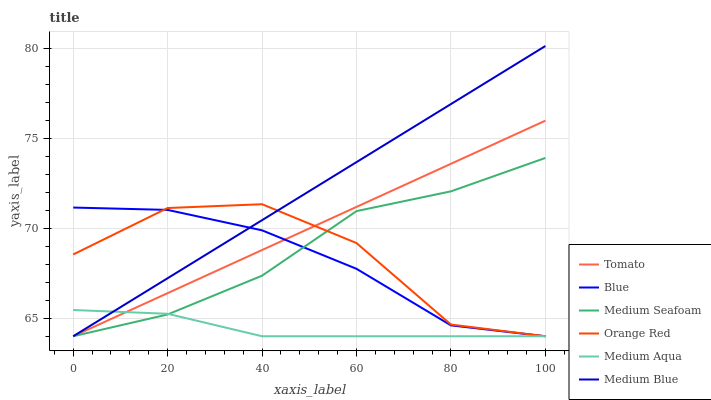Does Medium Aqua have the minimum area under the curve?
Answer yes or no. Yes. Does Medium Blue have the maximum area under the curve?
Answer yes or no. Yes. Does Blue have the minimum area under the curve?
Answer yes or no. No. Does Blue have the maximum area under the curve?
Answer yes or no. No. Is Tomato the smoothest?
Answer yes or no. Yes. Is Orange Red the roughest?
Answer yes or no. Yes. Is Blue the smoothest?
Answer yes or no. No. Is Blue the roughest?
Answer yes or no. No. Does Tomato have the lowest value?
Answer yes or no. Yes. Does Medium Blue have the highest value?
Answer yes or no. Yes. Does Blue have the highest value?
Answer yes or no. No. Does Medium Seafoam intersect Medium Blue?
Answer yes or no. Yes. Is Medium Seafoam less than Medium Blue?
Answer yes or no. No. Is Medium Seafoam greater than Medium Blue?
Answer yes or no. No. 